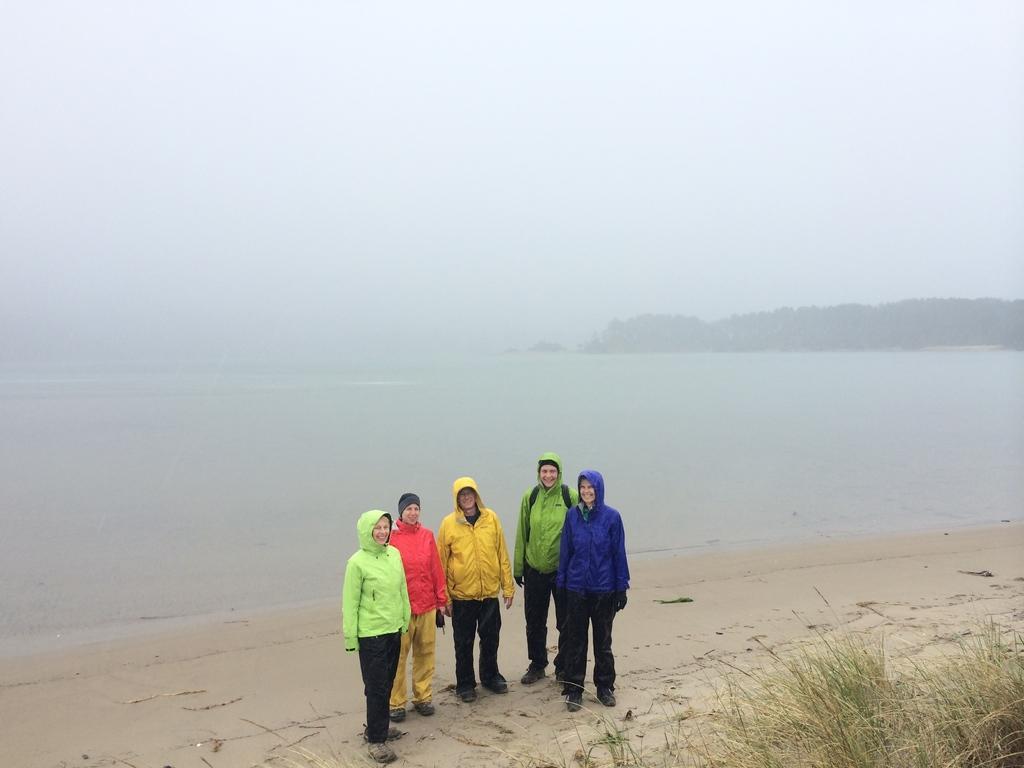Describe this image in one or two sentences. In the image I can see a sea shore on which there are some people wearing jackets and also I can see some plants and some mountains. 